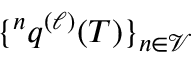<formula> <loc_0><loc_0><loc_500><loc_500>^ { n } q ^ { ( \ell ) } ( T ) \} _ { n \in \mathcal { V } }</formula> 